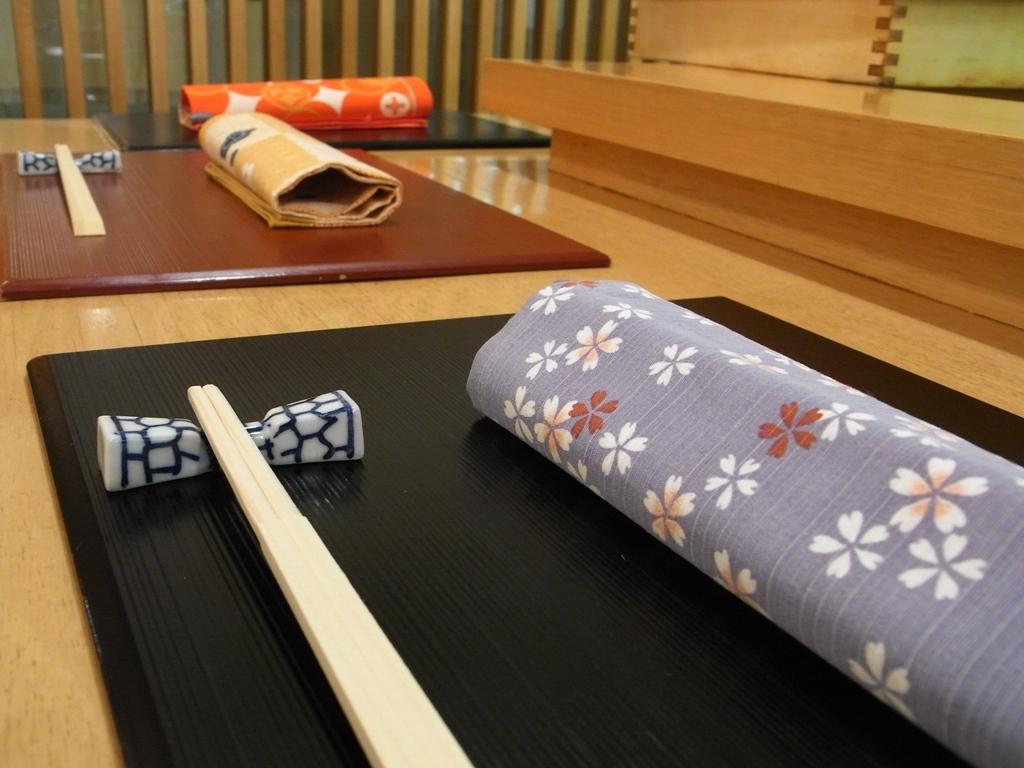Describe this image in one or two sentences. In the image we can see there is table on which there are cloth and chopsticks are kept. 